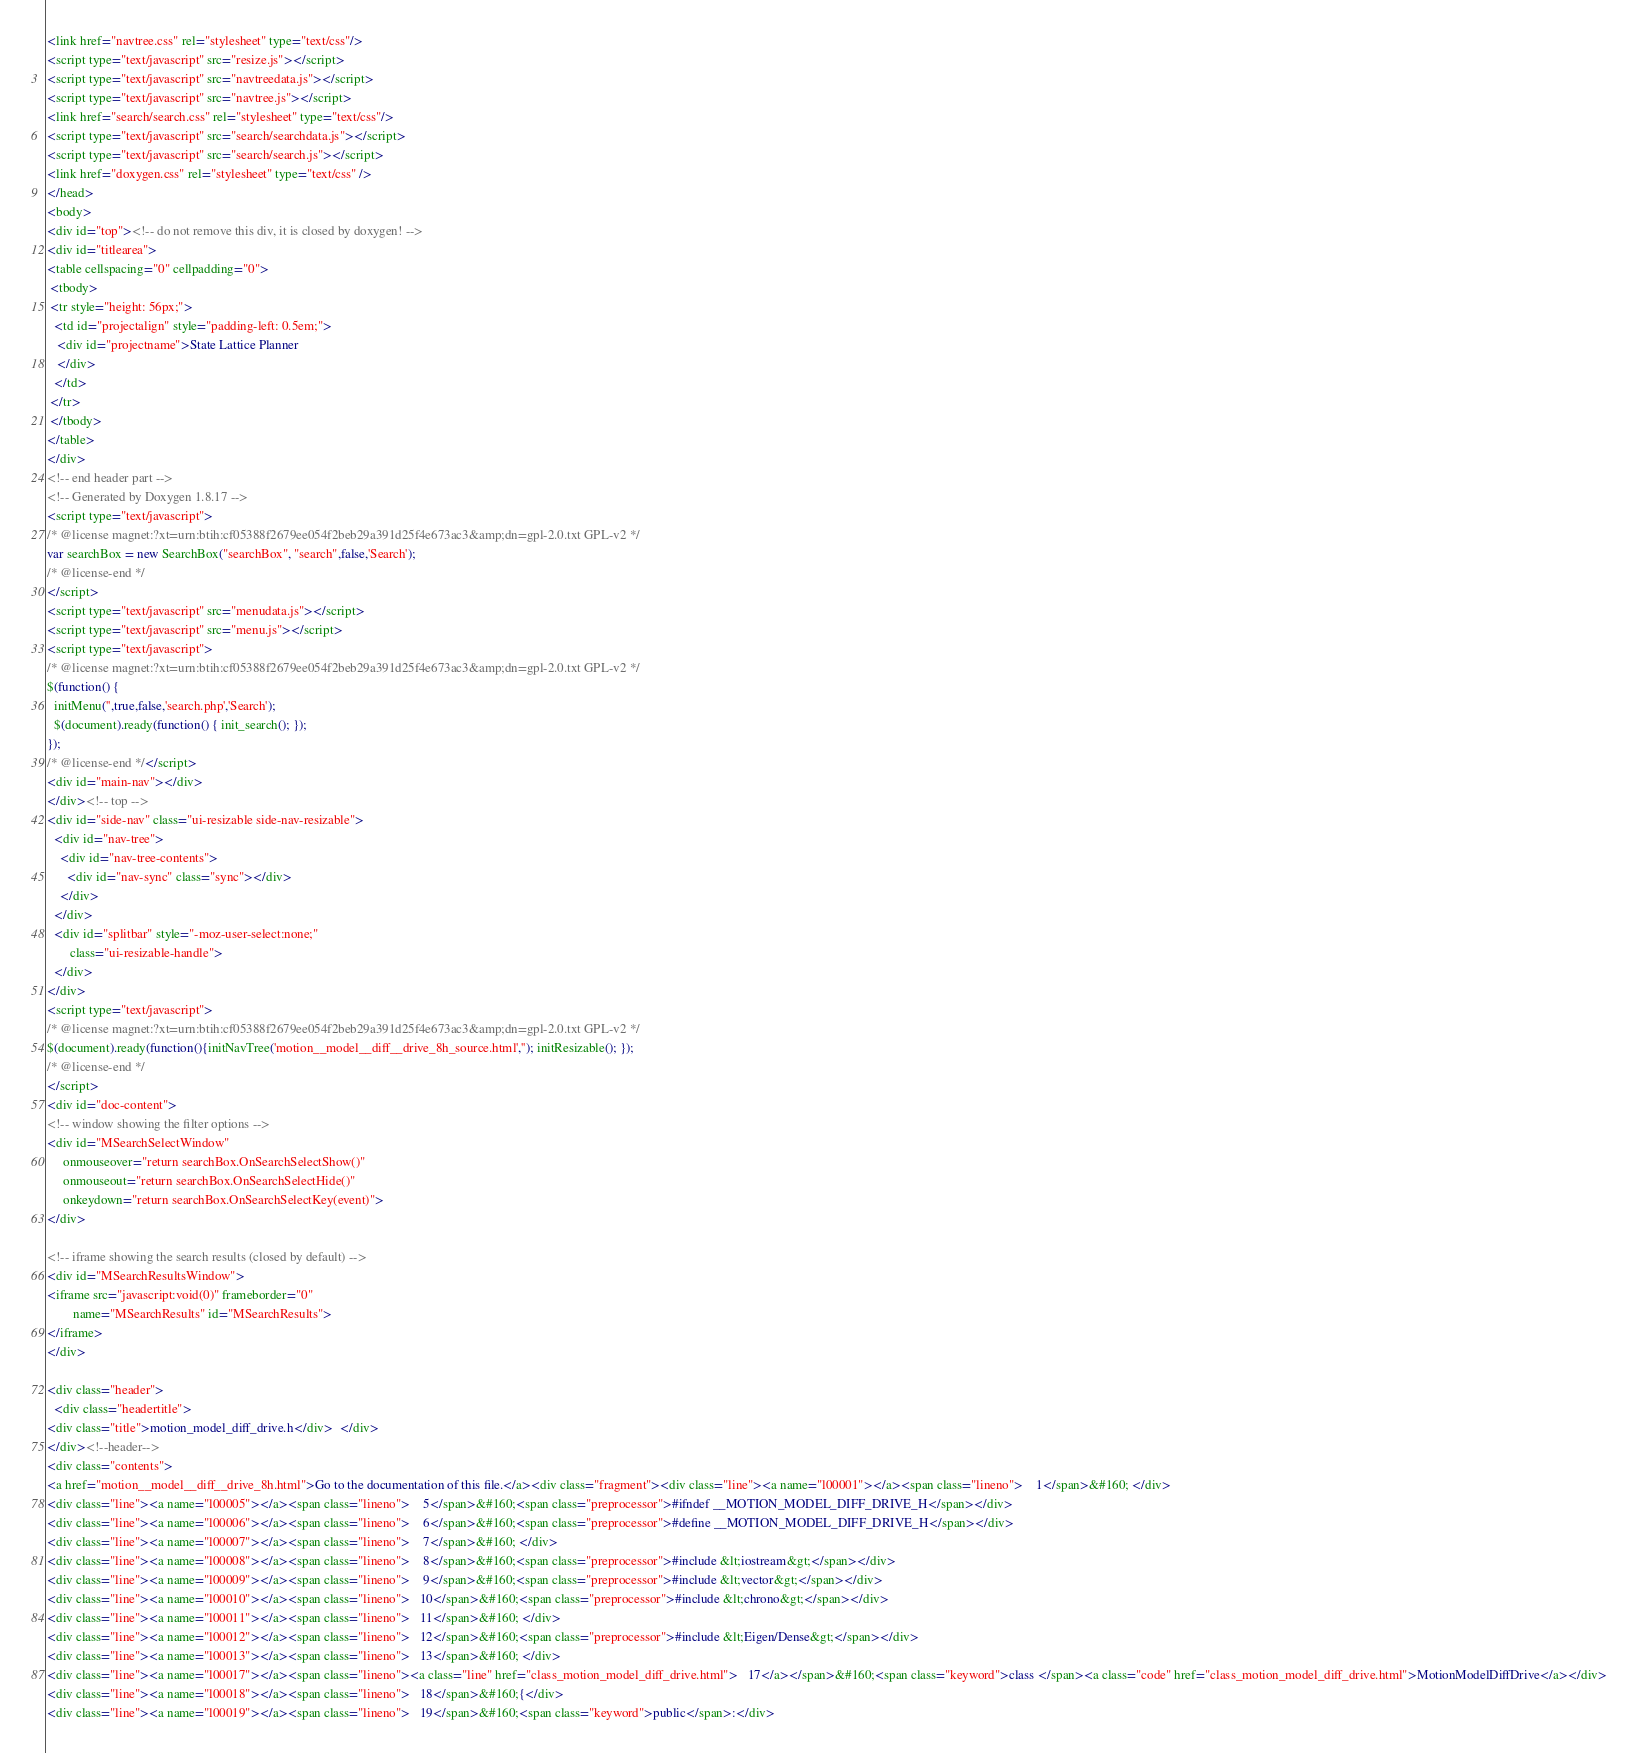<code> <loc_0><loc_0><loc_500><loc_500><_HTML_><link href="navtree.css" rel="stylesheet" type="text/css"/>
<script type="text/javascript" src="resize.js"></script>
<script type="text/javascript" src="navtreedata.js"></script>
<script type="text/javascript" src="navtree.js"></script>
<link href="search/search.css" rel="stylesheet" type="text/css"/>
<script type="text/javascript" src="search/searchdata.js"></script>
<script type="text/javascript" src="search/search.js"></script>
<link href="doxygen.css" rel="stylesheet" type="text/css" />
</head>
<body>
<div id="top"><!-- do not remove this div, it is closed by doxygen! -->
<div id="titlearea">
<table cellspacing="0" cellpadding="0">
 <tbody>
 <tr style="height: 56px;">
  <td id="projectalign" style="padding-left: 0.5em;">
   <div id="projectname">State Lattice Planner
   </div>
  </td>
 </tr>
 </tbody>
</table>
</div>
<!-- end header part -->
<!-- Generated by Doxygen 1.8.17 -->
<script type="text/javascript">
/* @license magnet:?xt=urn:btih:cf05388f2679ee054f2beb29a391d25f4e673ac3&amp;dn=gpl-2.0.txt GPL-v2 */
var searchBox = new SearchBox("searchBox", "search",false,'Search');
/* @license-end */
</script>
<script type="text/javascript" src="menudata.js"></script>
<script type="text/javascript" src="menu.js"></script>
<script type="text/javascript">
/* @license magnet:?xt=urn:btih:cf05388f2679ee054f2beb29a391d25f4e673ac3&amp;dn=gpl-2.0.txt GPL-v2 */
$(function() {
  initMenu('',true,false,'search.php','Search');
  $(document).ready(function() { init_search(); });
});
/* @license-end */</script>
<div id="main-nav"></div>
</div><!-- top -->
<div id="side-nav" class="ui-resizable side-nav-resizable">
  <div id="nav-tree">
    <div id="nav-tree-contents">
      <div id="nav-sync" class="sync"></div>
    </div>
  </div>
  <div id="splitbar" style="-moz-user-select:none;" 
       class="ui-resizable-handle">
  </div>
</div>
<script type="text/javascript">
/* @license magnet:?xt=urn:btih:cf05388f2679ee054f2beb29a391d25f4e673ac3&amp;dn=gpl-2.0.txt GPL-v2 */
$(document).ready(function(){initNavTree('motion__model__diff__drive_8h_source.html',''); initResizable(); });
/* @license-end */
</script>
<div id="doc-content">
<!-- window showing the filter options -->
<div id="MSearchSelectWindow"
     onmouseover="return searchBox.OnSearchSelectShow()"
     onmouseout="return searchBox.OnSearchSelectHide()"
     onkeydown="return searchBox.OnSearchSelectKey(event)">
</div>

<!-- iframe showing the search results (closed by default) -->
<div id="MSearchResultsWindow">
<iframe src="javascript:void(0)" frameborder="0" 
        name="MSearchResults" id="MSearchResults">
</iframe>
</div>

<div class="header">
  <div class="headertitle">
<div class="title">motion_model_diff_drive.h</div>  </div>
</div><!--header-->
<div class="contents">
<a href="motion__model__diff__drive_8h.html">Go to the documentation of this file.</a><div class="fragment"><div class="line"><a name="l00001"></a><span class="lineno">    1</span>&#160; </div>
<div class="line"><a name="l00005"></a><span class="lineno">    5</span>&#160;<span class="preprocessor">#ifndef __MOTION_MODEL_DIFF_DRIVE_H</span></div>
<div class="line"><a name="l00006"></a><span class="lineno">    6</span>&#160;<span class="preprocessor">#define __MOTION_MODEL_DIFF_DRIVE_H</span></div>
<div class="line"><a name="l00007"></a><span class="lineno">    7</span>&#160; </div>
<div class="line"><a name="l00008"></a><span class="lineno">    8</span>&#160;<span class="preprocessor">#include &lt;iostream&gt;</span></div>
<div class="line"><a name="l00009"></a><span class="lineno">    9</span>&#160;<span class="preprocessor">#include &lt;vector&gt;</span></div>
<div class="line"><a name="l00010"></a><span class="lineno">   10</span>&#160;<span class="preprocessor">#include &lt;chrono&gt;</span></div>
<div class="line"><a name="l00011"></a><span class="lineno">   11</span>&#160; </div>
<div class="line"><a name="l00012"></a><span class="lineno">   12</span>&#160;<span class="preprocessor">#include &lt;Eigen/Dense&gt;</span></div>
<div class="line"><a name="l00013"></a><span class="lineno">   13</span>&#160; </div>
<div class="line"><a name="l00017"></a><span class="lineno"><a class="line" href="class_motion_model_diff_drive.html">   17</a></span>&#160;<span class="keyword">class </span><a class="code" href="class_motion_model_diff_drive.html">MotionModelDiffDrive</a></div>
<div class="line"><a name="l00018"></a><span class="lineno">   18</span>&#160;{</div>
<div class="line"><a name="l00019"></a><span class="lineno">   19</span>&#160;<span class="keyword">public</span>:</div></code> 